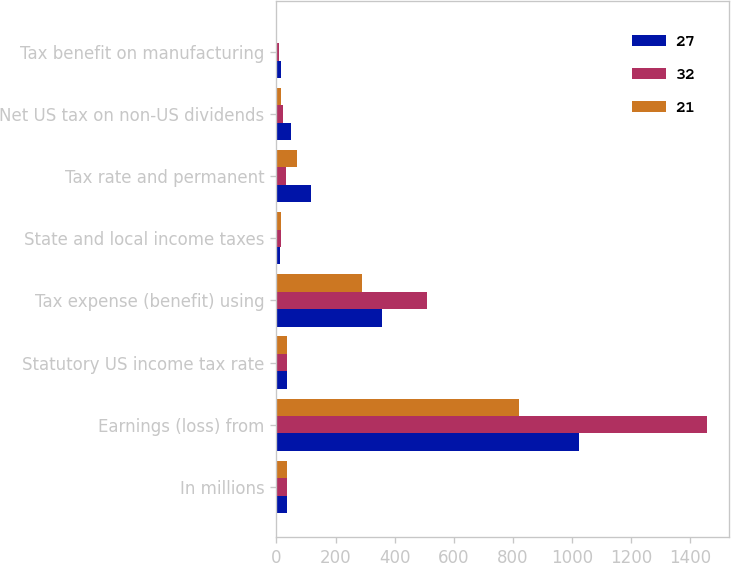Convert chart. <chart><loc_0><loc_0><loc_500><loc_500><stacked_bar_chart><ecel><fcel>In millions<fcel>Earnings (loss) from<fcel>Statutory US income tax rate<fcel>Tax expense (benefit) using<fcel>State and local income taxes<fcel>Tax rate and permanent<fcel>Net US tax on non-US dividends<fcel>Tax benefit on manufacturing<nl><fcel>27<fcel>35<fcel>1024<fcel>35<fcel>358<fcel>11<fcel>116<fcel>48<fcel>15<nl><fcel>32<fcel>35<fcel>1458<fcel>35<fcel>510<fcel>16<fcel>34<fcel>23<fcel>8<nl><fcel>21<fcel>35<fcel>822<fcel>35<fcel>288<fcel>15<fcel>69<fcel>16<fcel>3<nl></chart> 